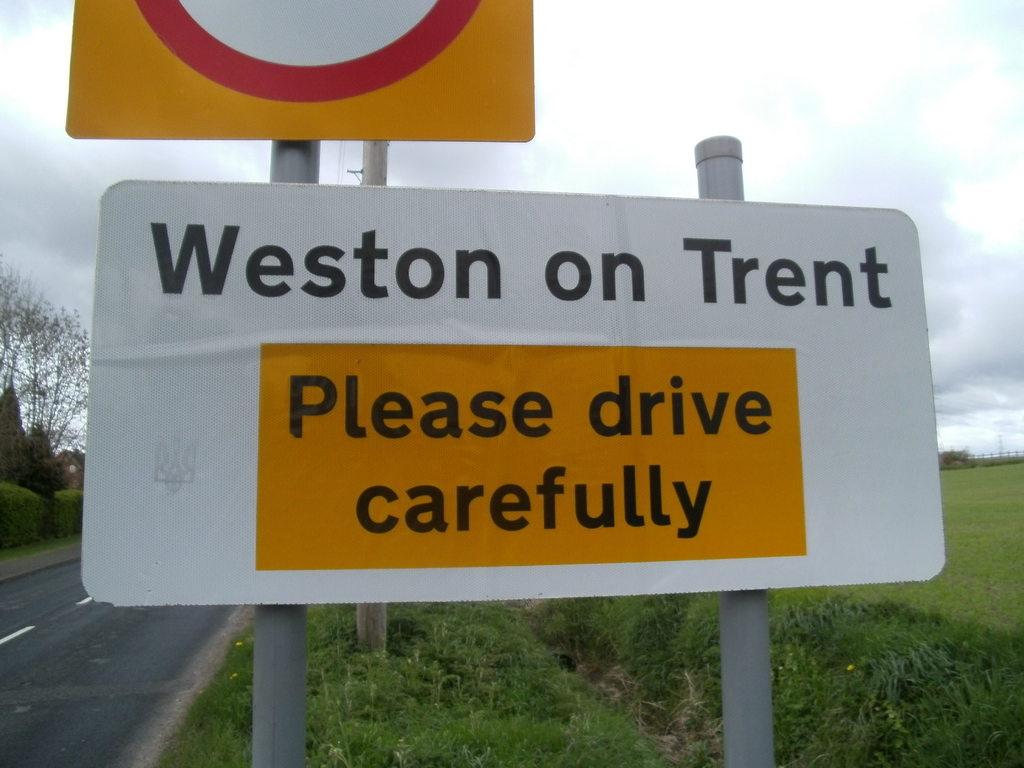What does the sign in orange say?
Ensure brevity in your answer.  Please drive carefully. 